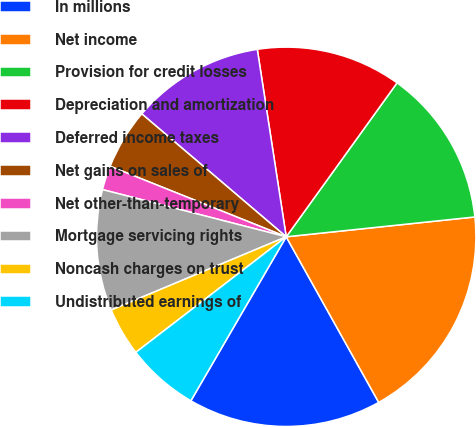<chart> <loc_0><loc_0><loc_500><loc_500><pie_chart><fcel>In millions<fcel>Net income<fcel>Provision for credit losses<fcel>Depreciation and amortization<fcel>Deferred income taxes<fcel>Net gains on sales of<fcel>Net other-than-temporary<fcel>Mortgage servicing rights<fcel>Noncash charges on trust<fcel>Undistributed earnings of<nl><fcel>16.49%<fcel>18.56%<fcel>13.4%<fcel>12.37%<fcel>11.34%<fcel>5.16%<fcel>2.06%<fcel>10.31%<fcel>4.12%<fcel>6.19%<nl></chart> 